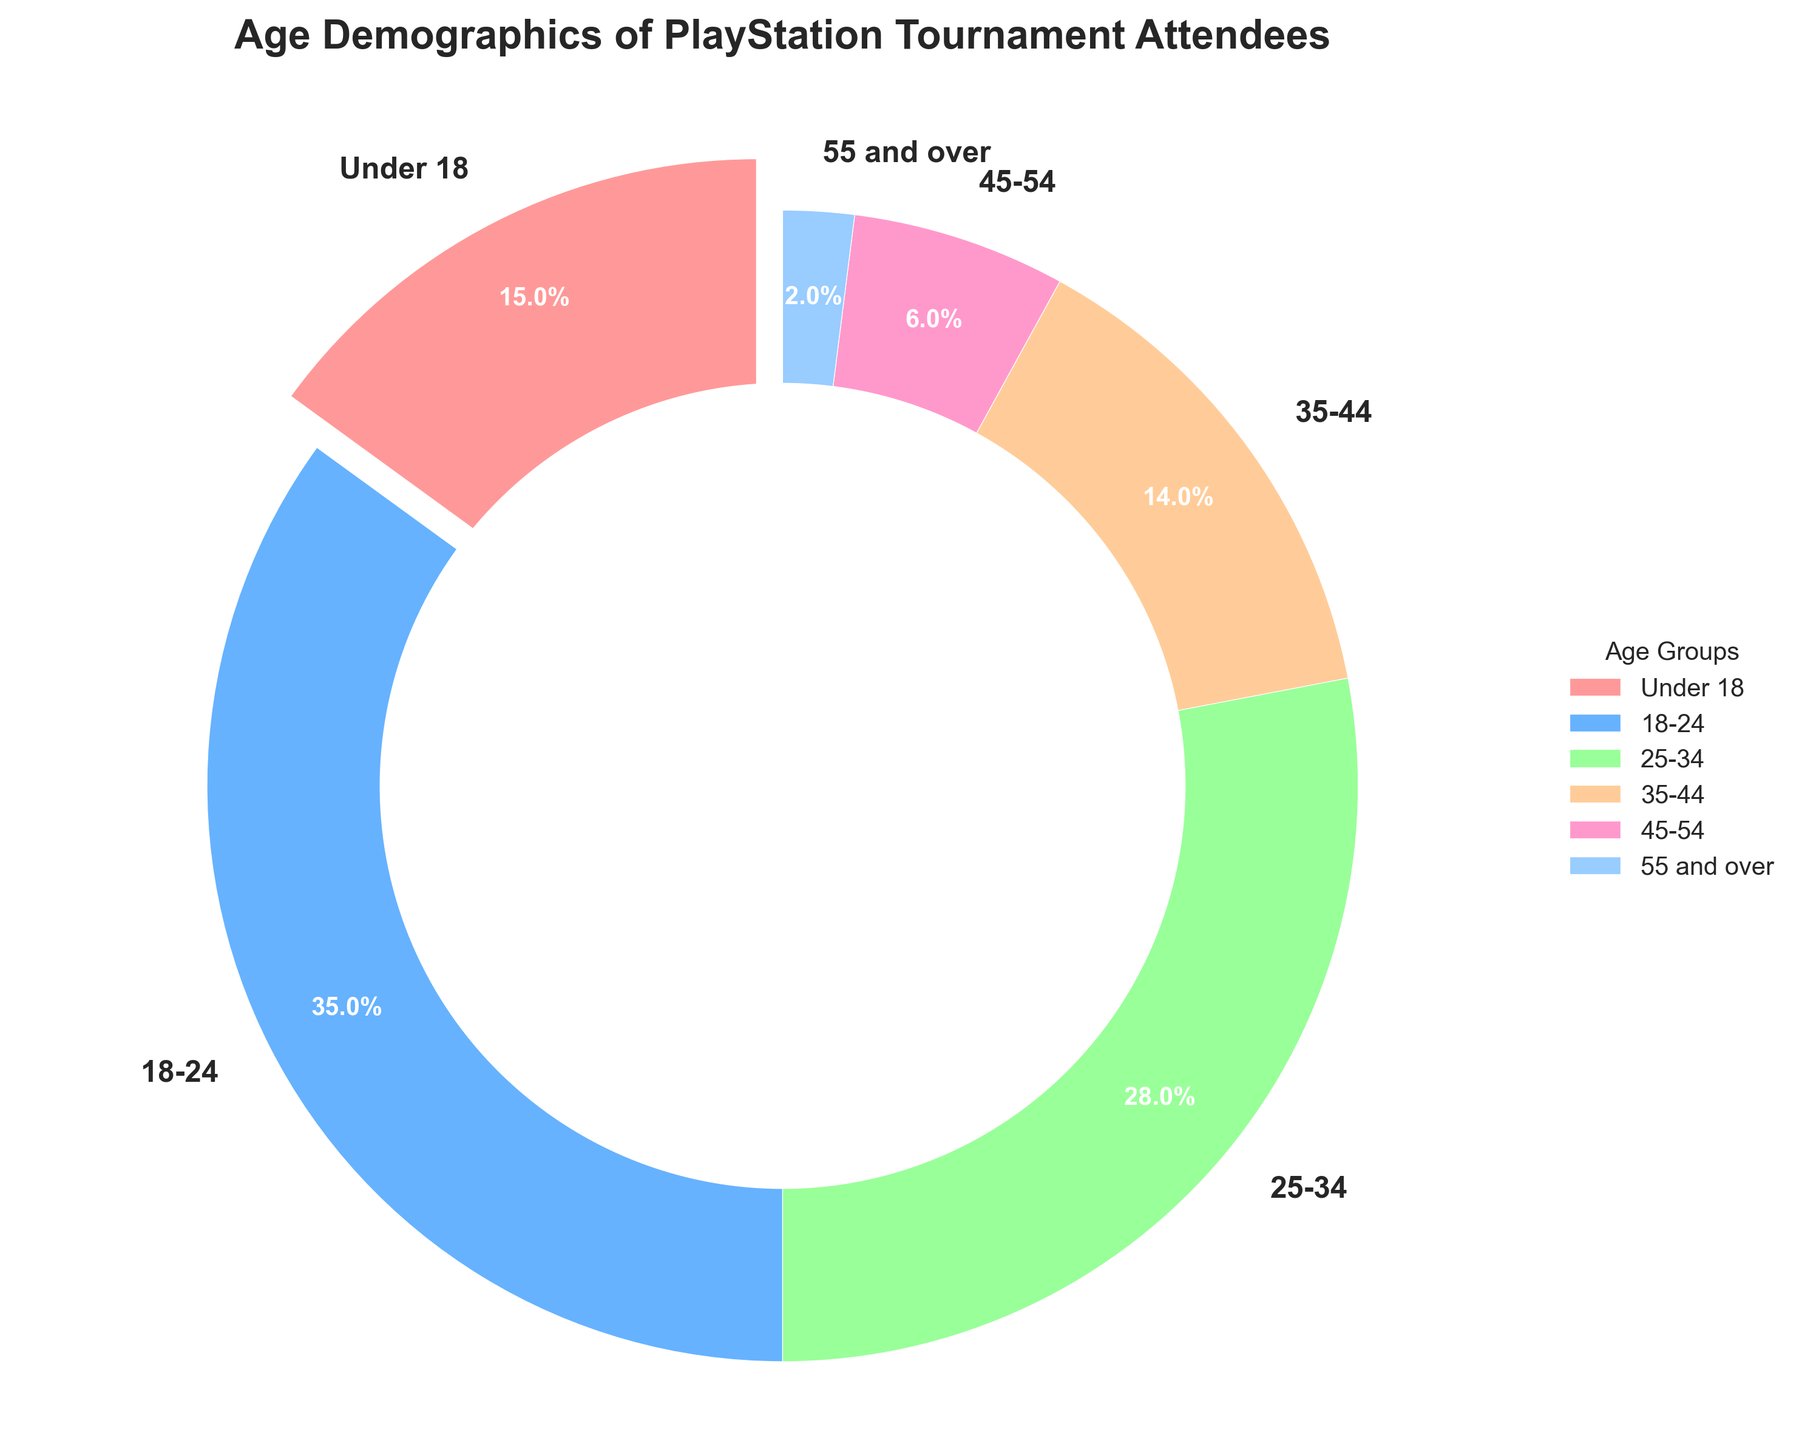What is the most common age group among the tournament attendees? The figure's pie chart shows the proportion of each age group. The 18-24 age group occupies the largest segment with 35%.
Answer: 18-24 Which age group has the smallest proportion of attendees? By visual inspection, the smallest wedge in the pie chart is the 55 and over age group with 2%.
Answer: 55 and over What percentage of attendees are 25 years old or older? Sum the percentages of the 25-34, 35-44, 45-54, and 55 and over groups: 28% + 14% + 6% + 2% = 50%.
Answer: 50% How does the proportion of attendees aged 18-24 compare to those under 18? The proportion of attendees aged 18-24 is 35%, and the proportion of those under 18 is 15%. So, the 18-24 group is more than twice as large.
Answer: 18-24 > Under 18 What is the visual design enhancement that helps differentiate the 'Under 18' age group from the others? The 'Under 18' section of the pie chart is slightly pulled out (exploded) from the rest, making it more distinct visually.
Answer: Explode effect How many age groups are there, and what is the average percentage representation of each? There are 6 age groups in the chart. Calculate the average by summing all percentages and dividing by 6: (15 + 35 + 28 + 14 + 6 + 2) / 6 = 100% / 6 ≈ 16.67%.
Answer: 16.67% Compare the total percentage of attendees under 25 to those 25 and older. Sum the percentages under 25: 15% (Under 18) + 35% (18-24) = 50%. For 25 and older: 50% (as calculated earlier). Both totals are equal.
Answer: Equal What color represents the 35-44 age group in the pie chart? By visual inspection, the 35-44 age group is represented in orange or a similar shade of color in the pie chart.
Answer: Orange 